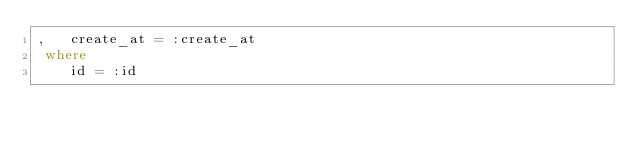<code> <loc_0><loc_0><loc_500><loc_500><_SQL_>,   create_at = :create_at
 where
    id = :id

</code> 